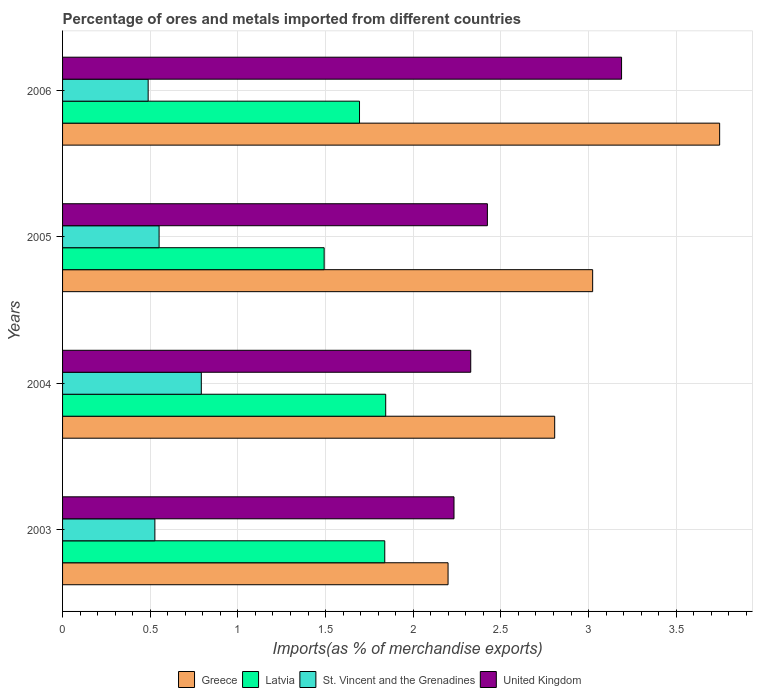How many different coloured bars are there?
Give a very brief answer. 4. What is the label of the 4th group of bars from the top?
Make the answer very short. 2003. In how many cases, is the number of bars for a given year not equal to the number of legend labels?
Keep it short and to the point. 0. What is the percentage of imports to different countries in St. Vincent and the Grenadines in 2006?
Make the answer very short. 0.49. Across all years, what is the maximum percentage of imports to different countries in Greece?
Offer a terse response. 3.75. Across all years, what is the minimum percentage of imports to different countries in Greece?
Your response must be concise. 2.2. In which year was the percentage of imports to different countries in St. Vincent and the Grenadines maximum?
Your response must be concise. 2004. What is the total percentage of imports to different countries in St. Vincent and the Grenadines in the graph?
Your response must be concise. 2.36. What is the difference between the percentage of imports to different countries in Latvia in 2005 and that in 2006?
Your answer should be compact. -0.2. What is the difference between the percentage of imports to different countries in St. Vincent and the Grenadines in 2006 and the percentage of imports to different countries in Latvia in 2003?
Make the answer very short. -1.35. What is the average percentage of imports to different countries in United Kingdom per year?
Your response must be concise. 2.54. In the year 2003, what is the difference between the percentage of imports to different countries in Latvia and percentage of imports to different countries in Greece?
Keep it short and to the point. -0.36. What is the ratio of the percentage of imports to different countries in St. Vincent and the Grenadines in 2005 to that in 2006?
Your answer should be compact. 1.13. Is the difference between the percentage of imports to different countries in Latvia in 2003 and 2006 greater than the difference between the percentage of imports to different countries in Greece in 2003 and 2006?
Give a very brief answer. Yes. What is the difference between the highest and the second highest percentage of imports to different countries in Greece?
Keep it short and to the point. 0.72. What is the difference between the highest and the lowest percentage of imports to different countries in Greece?
Your response must be concise. 1.55. In how many years, is the percentage of imports to different countries in St. Vincent and the Grenadines greater than the average percentage of imports to different countries in St. Vincent and the Grenadines taken over all years?
Keep it short and to the point. 1. Is the sum of the percentage of imports to different countries in Greece in 2003 and 2005 greater than the maximum percentage of imports to different countries in United Kingdom across all years?
Offer a very short reply. Yes. What does the 2nd bar from the top in 2003 represents?
Offer a terse response. St. Vincent and the Grenadines. What does the 2nd bar from the bottom in 2005 represents?
Your response must be concise. Latvia. Are all the bars in the graph horizontal?
Your answer should be compact. Yes. How many years are there in the graph?
Your response must be concise. 4. Are the values on the major ticks of X-axis written in scientific E-notation?
Your answer should be compact. No. Does the graph contain any zero values?
Your answer should be compact. No. Where does the legend appear in the graph?
Make the answer very short. Bottom center. How many legend labels are there?
Offer a terse response. 4. How are the legend labels stacked?
Your response must be concise. Horizontal. What is the title of the graph?
Ensure brevity in your answer.  Percentage of ores and metals imported from different countries. Does "Oman" appear as one of the legend labels in the graph?
Make the answer very short. No. What is the label or title of the X-axis?
Offer a terse response. Imports(as % of merchandise exports). What is the label or title of the Y-axis?
Your response must be concise. Years. What is the Imports(as % of merchandise exports) of Greece in 2003?
Offer a very short reply. 2.2. What is the Imports(as % of merchandise exports) in Latvia in 2003?
Offer a very short reply. 1.84. What is the Imports(as % of merchandise exports) of St. Vincent and the Grenadines in 2003?
Provide a succinct answer. 0.53. What is the Imports(as % of merchandise exports) in United Kingdom in 2003?
Keep it short and to the point. 2.23. What is the Imports(as % of merchandise exports) of Greece in 2004?
Provide a succinct answer. 2.81. What is the Imports(as % of merchandise exports) of Latvia in 2004?
Offer a terse response. 1.84. What is the Imports(as % of merchandise exports) in St. Vincent and the Grenadines in 2004?
Your response must be concise. 0.79. What is the Imports(as % of merchandise exports) in United Kingdom in 2004?
Your answer should be compact. 2.33. What is the Imports(as % of merchandise exports) of Greece in 2005?
Your response must be concise. 3.02. What is the Imports(as % of merchandise exports) in Latvia in 2005?
Your answer should be very brief. 1.49. What is the Imports(as % of merchandise exports) in St. Vincent and the Grenadines in 2005?
Provide a succinct answer. 0.55. What is the Imports(as % of merchandise exports) in United Kingdom in 2005?
Your response must be concise. 2.42. What is the Imports(as % of merchandise exports) in Greece in 2006?
Offer a terse response. 3.75. What is the Imports(as % of merchandise exports) of Latvia in 2006?
Your answer should be very brief. 1.69. What is the Imports(as % of merchandise exports) of St. Vincent and the Grenadines in 2006?
Keep it short and to the point. 0.49. What is the Imports(as % of merchandise exports) of United Kingdom in 2006?
Offer a terse response. 3.19. Across all years, what is the maximum Imports(as % of merchandise exports) in Greece?
Ensure brevity in your answer.  3.75. Across all years, what is the maximum Imports(as % of merchandise exports) of Latvia?
Your answer should be compact. 1.84. Across all years, what is the maximum Imports(as % of merchandise exports) in St. Vincent and the Grenadines?
Offer a very short reply. 0.79. Across all years, what is the maximum Imports(as % of merchandise exports) of United Kingdom?
Make the answer very short. 3.19. Across all years, what is the minimum Imports(as % of merchandise exports) in Greece?
Ensure brevity in your answer.  2.2. Across all years, what is the minimum Imports(as % of merchandise exports) in Latvia?
Make the answer very short. 1.49. Across all years, what is the minimum Imports(as % of merchandise exports) of St. Vincent and the Grenadines?
Your response must be concise. 0.49. Across all years, what is the minimum Imports(as % of merchandise exports) of United Kingdom?
Keep it short and to the point. 2.23. What is the total Imports(as % of merchandise exports) in Greece in the graph?
Your response must be concise. 11.78. What is the total Imports(as % of merchandise exports) of Latvia in the graph?
Offer a terse response. 6.87. What is the total Imports(as % of merchandise exports) in St. Vincent and the Grenadines in the graph?
Your answer should be compact. 2.36. What is the total Imports(as % of merchandise exports) of United Kingdom in the graph?
Ensure brevity in your answer.  10.17. What is the difference between the Imports(as % of merchandise exports) of Greece in 2003 and that in 2004?
Keep it short and to the point. -0.61. What is the difference between the Imports(as % of merchandise exports) in Latvia in 2003 and that in 2004?
Your response must be concise. -0.01. What is the difference between the Imports(as % of merchandise exports) in St. Vincent and the Grenadines in 2003 and that in 2004?
Make the answer very short. -0.26. What is the difference between the Imports(as % of merchandise exports) of United Kingdom in 2003 and that in 2004?
Ensure brevity in your answer.  -0.1. What is the difference between the Imports(as % of merchandise exports) in Greece in 2003 and that in 2005?
Your answer should be compact. -0.82. What is the difference between the Imports(as % of merchandise exports) of Latvia in 2003 and that in 2005?
Provide a short and direct response. 0.35. What is the difference between the Imports(as % of merchandise exports) in St. Vincent and the Grenadines in 2003 and that in 2005?
Your answer should be compact. -0.02. What is the difference between the Imports(as % of merchandise exports) in United Kingdom in 2003 and that in 2005?
Offer a very short reply. -0.19. What is the difference between the Imports(as % of merchandise exports) of Greece in 2003 and that in 2006?
Make the answer very short. -1.55. What is the difference between the Imports(as % of merchandise exports) of Latvia in 2003 and that in 2006?
Make the answer very short. 0.14. What is the difference between the Imports(as % of merchandise exports) of St. Vincent and the Grenadines in 2003 and that in 2006?
Give a very brief answer. 0.04. What is the difference between the Imports(as % of merchandise exports) of United Kingdom in 2003 and that in 2006?
Your response must be concise. -0.96. What is the difference between the Imports(as % of merchandise exports) in Greece in 2004 and that in 2005?
Your response must be concise. -0.22. What is the difference between the Imports(as % of merchandise exports) in Latvia in 2004 and that in 2005?
Make the answer very short. 0.35. What is the difference between the Imports(as % of merchandise exports) of St. Vincent and the Grenadines in 2004 and that in 2005?
Ensure brevity in your answer.  0.24. What is the difference between the Imports(as % of merchandise exports) of United Kingdom in 2004 and that in 2005?
Provide a short and direct response. -0.1. What is the difference between the Imports(as % of merchandise exports) of Greece in 2004 and that in 2006?
Ensure brevity in your answer.  -0.94. What is the difference between the Imports(as % of merchandise exports) in Latvia in 2004 and that in 2006?
Your response must be concise. 0.15. What is the difference between the Imports(as % of merchandise exports) in St. Vincent and the Grenadines in 2004 and that in 2006?
Ensure brevity in your answer.  0.3. What is the difference between the Imports(as % of merchandise exports) of United Kingdom in 2004 and that in 2006?
Provide a short and direct response. -0.86. What is the difference between the Imports(as % of merchandise exports) in Greece in 2005 and that in 2006?
Your response must be concise. -0.72. What is the difference between the Imports(as % of merchandise exports) in Latvia in 2005 and that in 2006?
Ensure brevity in your answer.  -0.2. What is the difference between the Imports(as % of merchandise exports) in St. Vincent and the Grenadines in 2005 and that in 2006?
Ensure brevity in your answer.  0.06. What is the difference between the Imports(as % of merchandise exports) of United Kingdom in 2005 and that in 2006?
Make the answer very short. -0.77. What is the difference between the Imports(as % of merchandise exports) of Greece in 2003 and the Imports(as % of merchandise exports) of Latvia in 2004?
Offer a very short reply. 0.36. What is the difference between the Imports(as % of merchandise exports) of Greece in 2003 and the Imports(as % of merchandise exports) of St. Vincent and the Grenadines in 2004?
Offer a very short reply. 1.41. What is the difference between the Imports(as % of merchandise exports) of Greece in 2003 and the Imports(as % of merchandise exports) of United Kingdom in 2004?
Provide a short and direct response. -0.13. What is the difference between the Imports(as % of merchandise exports) of Latvia in 2003 and the Imports(as % of merchandise exports) of St. Vincent and the Grenadines in 2004?
Offer a very short reply. 1.05. What is the difference between the Imports(as % of merchandise exports) in Latvia in 2003 and the Imports(as % of merchandise exports) in United Kingdom in 2004?
Keep it short and to the point. -0.49. What is the difference between the Imports(as % of merchandise exports) in St. Vincent and the Grenadines in 2003 and the Imports(as % of merchandise exports) in United Kingdom in 2004?
Your answer should be compact. -1.8. What is the difference between the Imports(as % of merchandise exports) in Greece in 2003 and the Imports(as % of merchandise exports) in Latvia in 2005?
Make the answer very short. 0.71. What is the difference between the Imports(as % of merchandise exports) of Greece in 2003 and the Imports(as % of merchandise exports) of St. Vincent and the Grenadines in 2005?
Offer a very short reply. 1.65. What is the difference between the Imports(as % of merchandise exports) in Greece in 2003 and the Imports(as % of merchandise exports) in United Kingdom in 2005?
Your answer should be compact. -0.22. What is the difference between the Imports(as % of merchandise exports) in Latvia in 2003 and the Imports(as % of merchandise exports) in St. Vincent and the Grenadines in 2005?
Keep it short and to the point. 1.29. What is the difference between the Imports(as % of merchandise exports) in Latvia in 2003 and the Imports(as % of merchandise exports) in United Kingdom in 2005?
Ensure brevity in your answer.  -0.59. What is the difference between the Imports(as % of merchandise exports) of St. Vincent and the Grenadines in 2003 and the Imports(as % of merchandise exports) of United Kingdom in 2005?
Your answer should be compact. -1.9. What is the difference between the Imports(as % of merchandise exports) of Greece in 2003 and the Imports(as % of merchandise exports) of Latvia in 2006?
Your response must be concise. 0.51. What is the difference between the Imports(as % of merchandise exports) in Greece in 2003 and the Imports(as % of merchandise exports) in St. Vincent and the Grenadines in 2006?
Make the answer very short. 1.71. What is the difference between the Imports(as % of merchandise exports) of Greece in 2003 and the Imports(as % of merchandise exports) of United Kingdom in 2006?
Offer a terse response. -0.99. What is the difference between the Imports(as % of merchandise exports) of Latvia in 2003 and the Imports(as % of merchandise exports) of St. Vincent and the Grenadines in 2006?
Make the answer very short. 1.35. What is the difference between the Imports(as % of merchandise exports) in Latvia in 2003 and the Imports(as % of merchandise exports) in United Kingdom in 2006?
Provide a short and direct response. -1.35. What is the difference between the Imports(as % of merchandise exports) in St. Vincent and the Grenadines in 2003 and the Imports(as % of merchandise exports) in United Kingdom in 2006?
Your response must be concise. -2.66. What is the difference between the Imports(as % of merchandise exports) of Greece in 2004 and the Imports(as % of merchandise exports) of Latvia in 2005?
Give a very brief answer. 1.31. What is the difference between the Imports(as % of merchandise exports) of Greece in 2004 and the Imports(as % of merchandise exports) of St. Vincent and the Grenadines in 2005?
Your answer should be very brief. 2.26. What is the difference between the Imports(as % of merchandise exports) of Greece in 2004 and the Imports(as % of merchandise exports) of United Kingdom in 2005?
Offer a terse response. 0.38. What is the difference between the Imports(as % of merchandise exports) in Latvia in 2004 and the Imports(as % of merchandise exports) in St. Vincent and the Grenadines in 2005?
Provide a short and direct response. 1.29. What is the difference between the Imports(as % of merchandise exports) of Latvia in 2004 and the Imports(as % of merchandise exports) of United Kingdom in 2005?
Provide a succinct answer. -0.58. What is the difference between the Imports(as % of merchandise exports) in St. Vincent and the Grenadines in 2004 and the Imports(as % of merchandise exports) in United Kingdom in 2005?
Your answer should be very brief. -1.63. What is the difference between the Imports(as % of merchandise exports) of Greece in 2004 and the Imports(as % of merchandise exports) of Latvia in 2006?
Provide a short and direct response. 1.11. What is the difference between the Imports(as % of merchandise exports) of Greece in 2004 and the Imports(as % of merchandise exports) of St. Vincent and the Grenadines in 2006?
Provide a short and direct response. 2.32. What is the difference between the Imports(as % of merchandise exports) in Greece in 2004 and the Imports(as % of merchandise exports) in United Kingdom in 2006?
Provide a succinct answer. -0.38. What is the difference between the Imports(as % of merchandise exports) in Latvia in 2004 and the Imports(as % of merchandise exports) in St. Vincent and the Grenadines in 2006?
Provide a short and direct response. 1.35. What is the difference between the Imports(as % of merchandise exports) of Latvia in 2004 and the Imports(as % of merchandise exports) of United Kingdom in 2006?
Offer a very short reply. -1.35. What is the difference between the Imports(as % of merchandise exports) in St. Vincent and the Grenadines in 2004 and the Imports(as % of merchandise exports) in United Kingdom in 2006?
Provide a short and direct response. -2.4. What is the difference between the Imports(as % of merchandise exports) of Greece in 2005 and the Imports(as % of merchandise exports) of Latvia in 2006?
Provide a short and direct response. 1.33. What is the difference between the Imports(as % of merchandise exports) of Greece in 2005 and the Imports(as % of merchandise exports) of St. Vincent and the Grenadines in 2006?
Keep it short and to the point. 2.54. What is the difference between the Imports(as % of merchandise exports) of Greece in 2005 and the Imports(as % of merchandise exports) of United Kingdom in 2006?
Provide a short and direct response. -0.16. What is the difference between the Imports(as % of merchandise exports) of Latvia in 2005 and the Imports(as % of merchandise exports) of St. Vincent and the Grenadines in 2006?
Your answer should be very brief. 1. What is the difference between the Imports(as % of merchandise exports) of Latvia in 2005 and the Imports(as % of merchandise exports) of United Kingdom in 2006?
Your response must be concise. -1.7. What is the difference between the Imports(as % of merchandise exports) of St. Vincent and the Grenadines in 2005 and the Imports(as % of merchandise exports) of United Kingdom in 2006?
Offer a terse response. -2.64. What is the average Imports(as % of merchandise exports) of Greece per year?
Provide a short and direct response. 2.94. What is the average Imports(as % of merchandise exports) in Latvia per year?
Your response must be concise. 1.72. What is the average Imports(as % of merchandise exports) of St. Vincent and the Grenadines per year?
Give a very brief answer. 0.59. What is the average Imports(as % of merchandise exports) in United Kingdom per year?
Ensure brevity in your answer.  2.54. In the year 2003, what is the difference between the Imports(as % of merchandise exports) in Greece and Imports(as % of merchandise exports) in Latvia?
Your answer should be compact. 0.36. In the year 2003, what is the difference between the Imports(as % of merchandise exports) of Greece and Imports(as % of merchandise exports) of St. Vincent and the Grenadines?
Make the answer very short. 1.67. In the year 2003, what is the difference between the Imports(as % of merchandise exports) in Greece and Imports(as % of merchandise exports) in United Kingdom?
Offer a terse response. -0.03. In the year 2003, what is the difference between the Imports(as % of merchandise exports) of Latvia and Imports(as % of merchandise exports) of St. Vincent and the Grenadines?
Your answer should be compact. 1.31. In the year 2003, what is the difference between the Imports(as % of merchandise exports) in Latvia and Imports(as % of merchandise exports) in United Kingdom?
Provide a short and direct response. -0.39. In the year 2003, what is the difference between the Imports(as % of merchandise exports) of St. Vincent and the Grenadines and Imports(as % of merchandise exports) of United Kingdom?
Offer a terse response. -1.71. In the year 2004, what is the difference between the Imports(as % of merchandise exports) in Greece and Imports(as % of merchandise exports) in Latvia?
Provide a succinct answer. 0.96. In the year 2004, what is the difference between the Imports(as % of merchandise exports) in Greece and Imports(as % of merchandise exports) in St. Vincent and the Grenadines?
Provide a short and direct response. 2.02. In the year 2004, what is the difference between the Imports(as % of merchandise exports) of Greece and Imports(as % of merchandise exports) of United Kingdom?
Offer a very short reply. 0.48. In the year 2004, what is the difference between the Imports(as % of merchandise exports) in Latvia and Imports(as % of merchandise exports) in St. Vincent and the Grenadines?
Make the answer very short. 1.05. In the year 2004, what is the difference between the Imports(as % of merchandise exports) of Latvia and Imports(as % of merchandise exports) of United Kingdom?
Ensure brevity in your answer.  -0.48. In the year 2004, what is the difference between the Imports(as % of merchandise exports) in St. Vincent and the Grenadines and Imports(as % of merchandise exports) in United Kingdom?
Your response must be concise. -1.54. In the year 2005, what is the difference between the Imports(as % of merchandise exports) of Greece and Imports(as % of merchandise exports) of Latvia?
Provide a succinct answer. 1.53. In the year 2005, what is the difference between the Imports(as % of merchandise exports) of Greece and Imports(as % of merchandise exports) of St. Vincent and the Grenadines?
Give a very brief answer. 2.47. In the year 2005, what is the difference between the Imports(as % of merchandise exports) of Greece and Imports(as % of merchandise exports) of United Kingdom?
Your response must be concise. 0.6. In the year 2005, what is the difference between the Imports(as % of merchandise exports) of Latvia and Imports(as % of merchandise exports) of St. Vincent and the Grenadines?
Offer a very short reply. 0.94. In the year 2005, what is the difference between the Imports(as % of merchandise exports) of Latvia and Imports(as % of merchandise exports) of United Kingdom?
Make the answer very short. -0.93. In the year 2005, what is the difference between the Imports(as % of merchandise exports) in St. Vincent and the Grenadines and Imports(as % of merchandise exports) in United Kingdom?
Your answer should be very brief. -1.87. In the year 2006, what is the difference between the Imports(as % of merchandise exports) in Greece and Imports(as % of merchandise exports) in Latvia?
Offer a terse response. 2.05. In the year 2006, what is the difference between the Imports(as % of merchandise exports) in Greece and Imports(as % of merchandise exports) in St. Vincent and the Grenadines?
Your answer should be compact. 3.26. In the year 2006, what is the difference between the Imports(as % of merchandise exports) in Greece and Imports(as % of merchandise exports) in United Kingdom?
Offer a very short reply. 0.56. In the year 2006, what is the difference between the Imports(as % of merchandise exports) of Latvia and Imports(as % of merchandise exports) of St. Vincent and the Grenadines?
Your response must be concise. 1.21. In the year 2006, what is the difference between the Imports(as % of merchandise exports) of Latvia and Imports(as % of merchandise exports) of United Kingdom?
Offer a terse response. -1.49. In the year 2006, what is the difference between the Imports(as % of merchandise exports) of St. Vincent and the Grenadines and Imports(as % of merchandise exports) of United Kingdom?
Ensure brevity in your answer.  -2.7. What is the ratio of the Imports(as % of merchandise exports) in Greece in 2003 to that in 2004?
Your answer should be compact. 0.78. What is the ratio of the Imports(as % of merchandise exports) in St. Vincent and the Grenadines in 2003 to that in 2004?
Your answer should be very brief. 0.67. What is the ratio of the Imports(as % of merchandise exports) of Greece in 2003 to that in 2005?
Your answer should be compact. 0.73. What is the ratio of the Imports(as % of merchandise exports) of Latvia in 2003 to that in 2005?
Your response must be concise. 1.23. What is the ratio of the Imports(as % of merchandise exports) in St. Vincent and the Grenadines in 2003 to that in 2005?
Keep it short and to the point. 0.96. What is the ratio of the Imports(as % of merchandise exports) of United Kingdom in 2003 to that in 2005?
Your answer should be compact. 0.92. What is the ratio of the Imports(as % of merchandise exports) of Greece in 2003 to that in 2006?
Your response must be concise. 0.59. What is the ratio of the Imports(as % of merchandise exports) in Latvia in 2003 to that in 2006?
Provide a succinct answer. 1.08. What is the ratio of the Imports(as % of merchandise exports) of St. Vincent and the Grenadines in 2003 to that in 2006?
Make the answer very short. 1.08. What is the ratio of the Imports(as % of merchandise exports) in United Kingdom in 2003 to that in 2006?
Keep it short and to the point. 0.7. What is the ratio of the Imports(as % of merchandise exports) in Greece in 2004 to that in 2005?
Offer a very short reply. 0.93. What is the ratio of the Imports(as % of merchandise exports) in Latvia in 2004 to that in 2005?
Ensure brevity in your answer.  1.24. What is the ratio of the Imports(as % of merchandise exports) in St. Vincent and the Grenadines in 2004 to that in 2005?
Your answer should be compact. 1.44. What is the ratio of the Imports(as % of merchandise exports) of United Kingdom in 2004 to that in 2005?
Your response must be concise. 0.96. What is the ratio of the Imports(as % of merchandise exports) of Greece in 2004 to that in 2006?
Provide a short and direct response. 0.75. What is the ratio of the Imports(as % of merchandise exports) in Latvia in 2004 to that in 2006?
Your answer should be very brief. 1.09. What is the ratio of the Imports(as % of merchandise exports) of St. Vincent and the Grenadines in 2004 to that in 2006?
Your answer should be very brief. 1.62. What is the ratio of the Imports(as % of merchandise exports) of United Kingdom in 2004 to that in 2006?
Make the answer very short. 0.73. What is the ratio of the Imports(as % of merchandise exports) of Greece in 2005 to that in 2006?
Provide a short and direct response. 0.81. What is the ratio of the Imports(as % of merchandise exports) in Latvia in 2005 to that in 2006?
Ensure brevity in your answer.  0.88. What is the ratio of the Imports(as % of merchandise exports) of St. Vincent and the Grenadines in 2005 to that in 2006?
Your answer should be very brief. 1.13. What is the ratio of the Imports(as % of merchandise exports) in United Kingdom in 2005 to that in 2006?
Make the answer very short. 0.76. What is the difference between the highest and the second highest Imports(as % of merchandise exports) in Greece?
Provide a succinct answer. 0.72. What is the difference between the highest and the second highest Imports(as % of merchandise exports) of Latvia?
Your response must be concise. 0.01. What is the difference between the highest and the second highest Imports(as % of merchandise exports) of St. Vincent and the Grenadines?
Make the answer very short. 0.24. What is the difference between the highest and the second highest Imports(as % of merchandise exports) in United Kingdom?
Make the answer very short. 0.77. What is the difference between the highest and the lowest Imports(as % of merchandise exports) of Greece?
Provide a short and direct response. 1.55. What is the difference between the highest and the lowest Imports(as % of merchandise exports) in Latvia?
Your answer should be compact. 0.35. What is the difference between the highest and the lowest Imports(as % of merchandise exports) in St. Vincent and the Grenadines?
Offer a very short reply. 0.3. What is the difference between the highest and the lowest Imports(as % of merchandise exports) in United Kingdom?
Offer a very short reply. 0.96. 